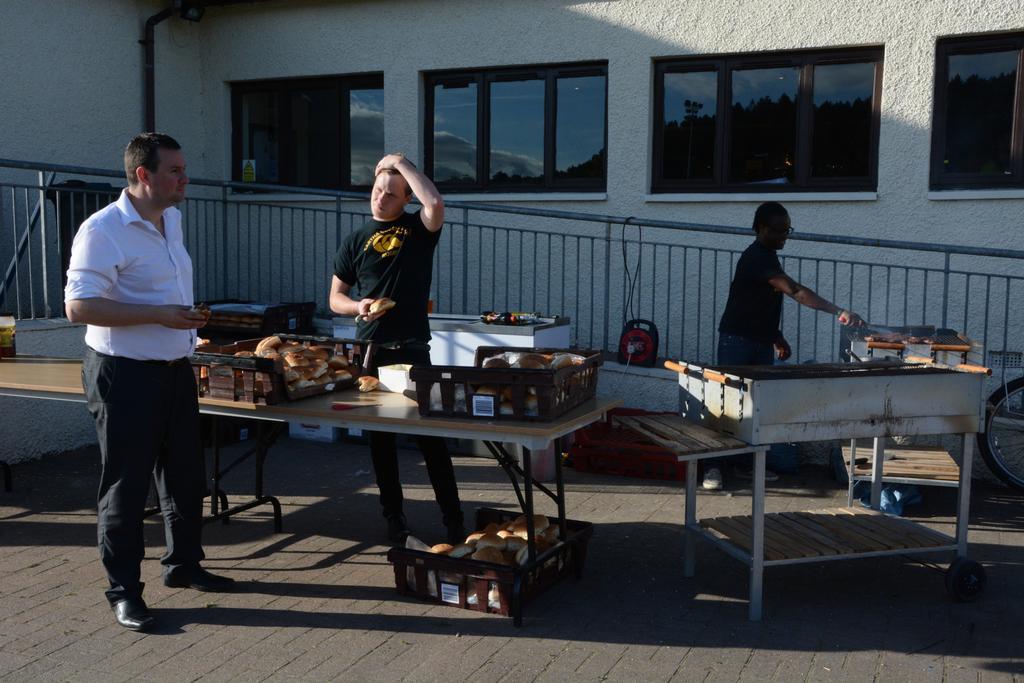Describe this image in one or two sentences. As we can see in the image there is a wall, three people over here and there is a table. 